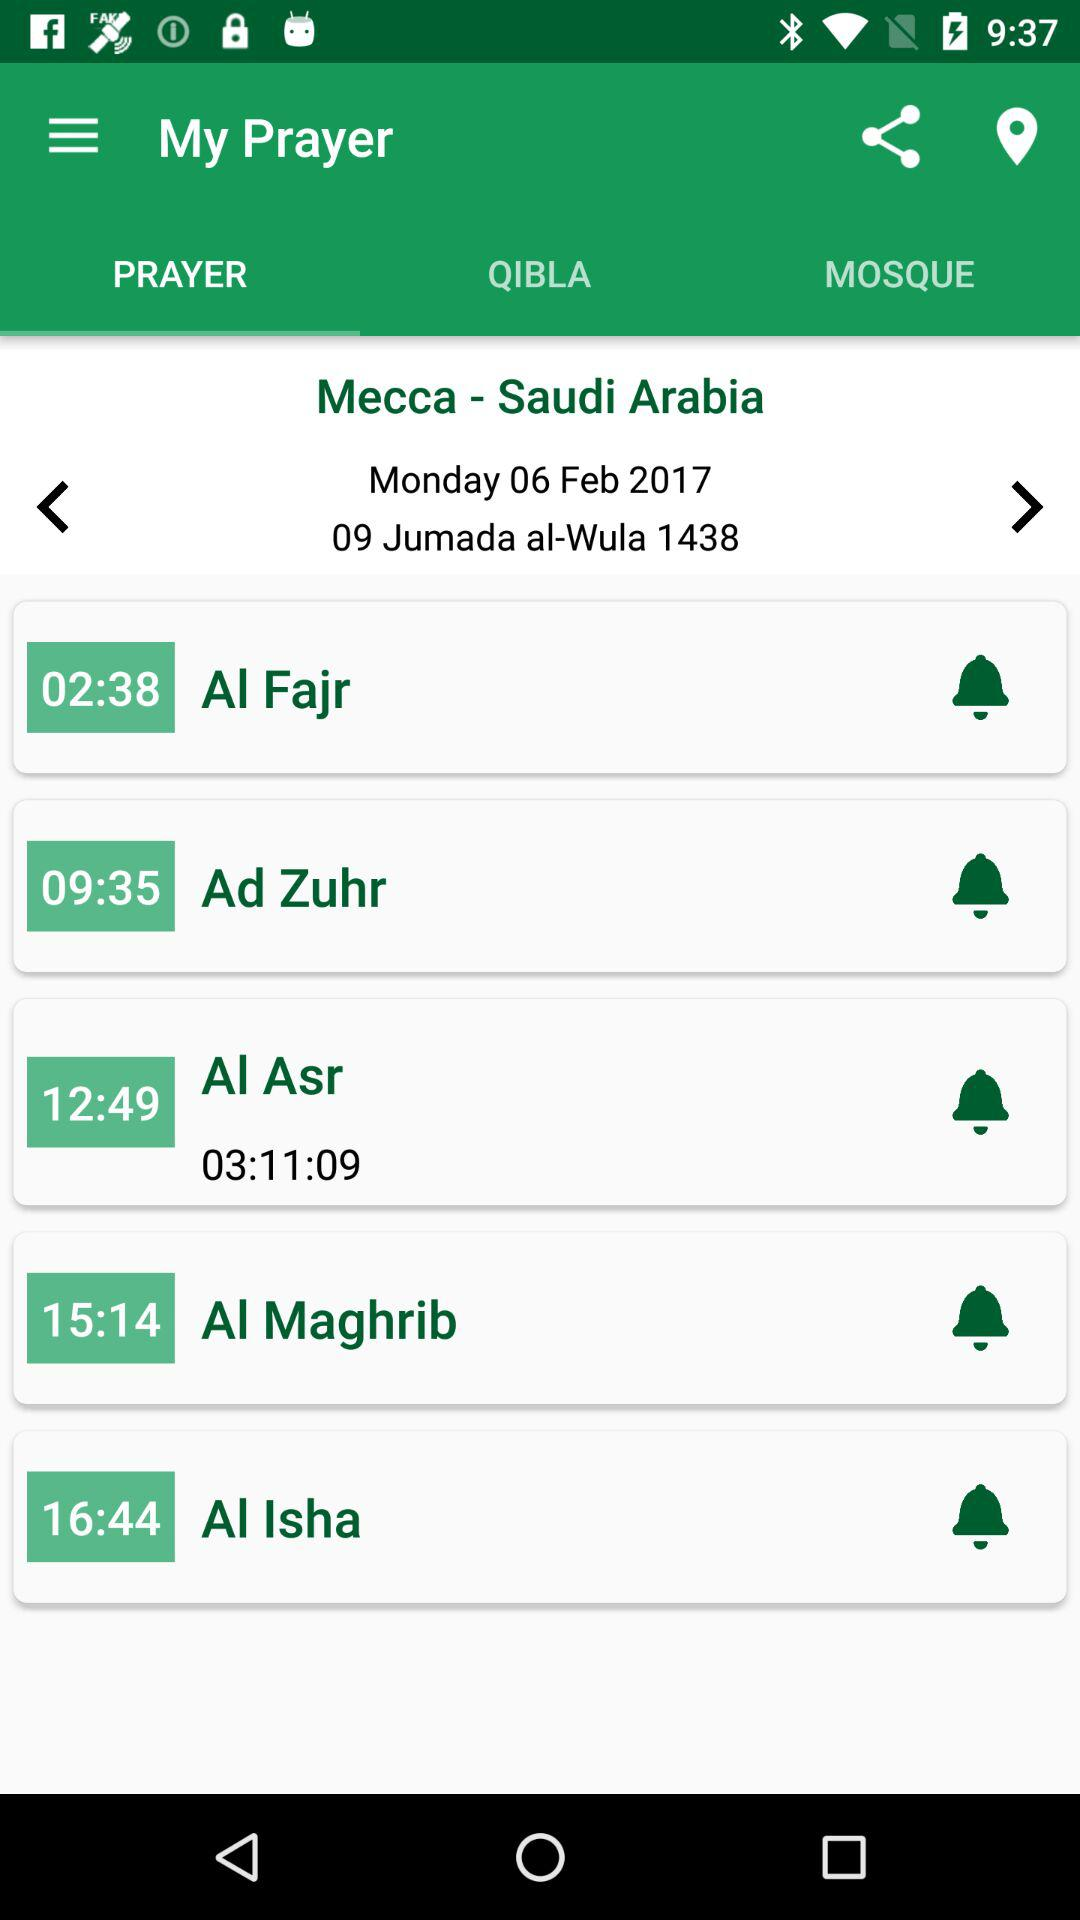What is the time of the "Al Fajr" prayer? The time of the "Al Fajr" prayer is 02:38. 